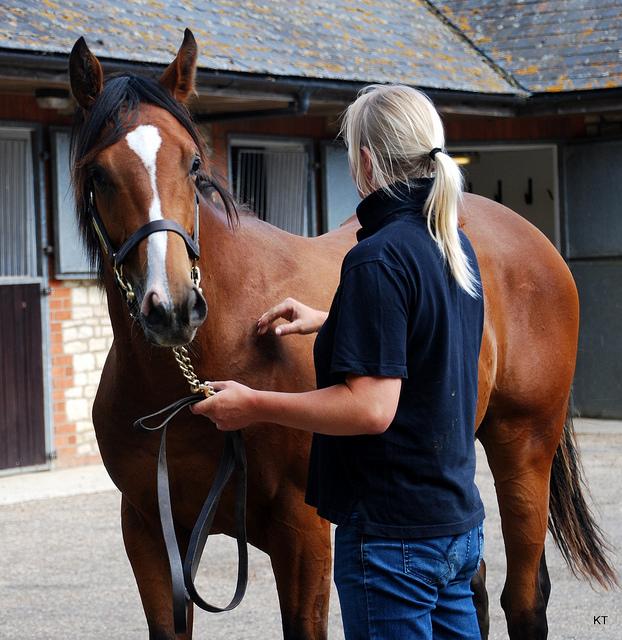How does she have her hair styled?
Concise answer only. Ponytail. Does the horse look friendly?
Concise answer only. Yes. Are the horses decorated?
Write a very short answer. No. Is there a saddle on the horse?
Write a very short answer. No. 